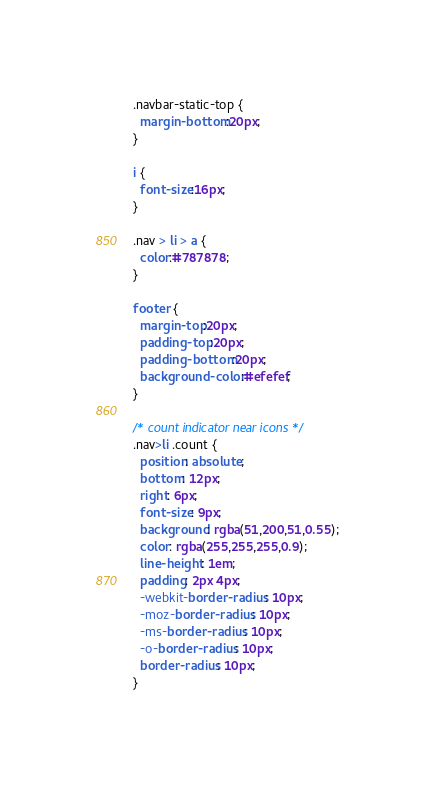Convert code to text. <code><loc_0><loc_0><loc_500><loc_500><_CSS_>.navbar-static-top {
  margin-bottom:20px;
}

i {
  font-size:16px;
}

.nav > li > a {
  color:#787878;
}
  
footer {
  margin-top:20px;
  padding-top:20px;
  padding-bottom:20px;
  background-color:#efefef;
}

/* count indicator near icons */
.nav>li .count {
  position: absolute;
  bottom: 12px;
  right: 6px;
  font-size: 9px;
  background: rgba(51,200,51,0.55);
  color: rgba(255,255,255,0.9);
  line-height: 1em;
  padding: 2px 4px;
  -webkit-border-radius: 10px;
  -moz-border-radius: 10px;
  -ms-border-radius: 10px;
  -o-border-radius: 10px;
  border-radius: 10px;
}
</code> 